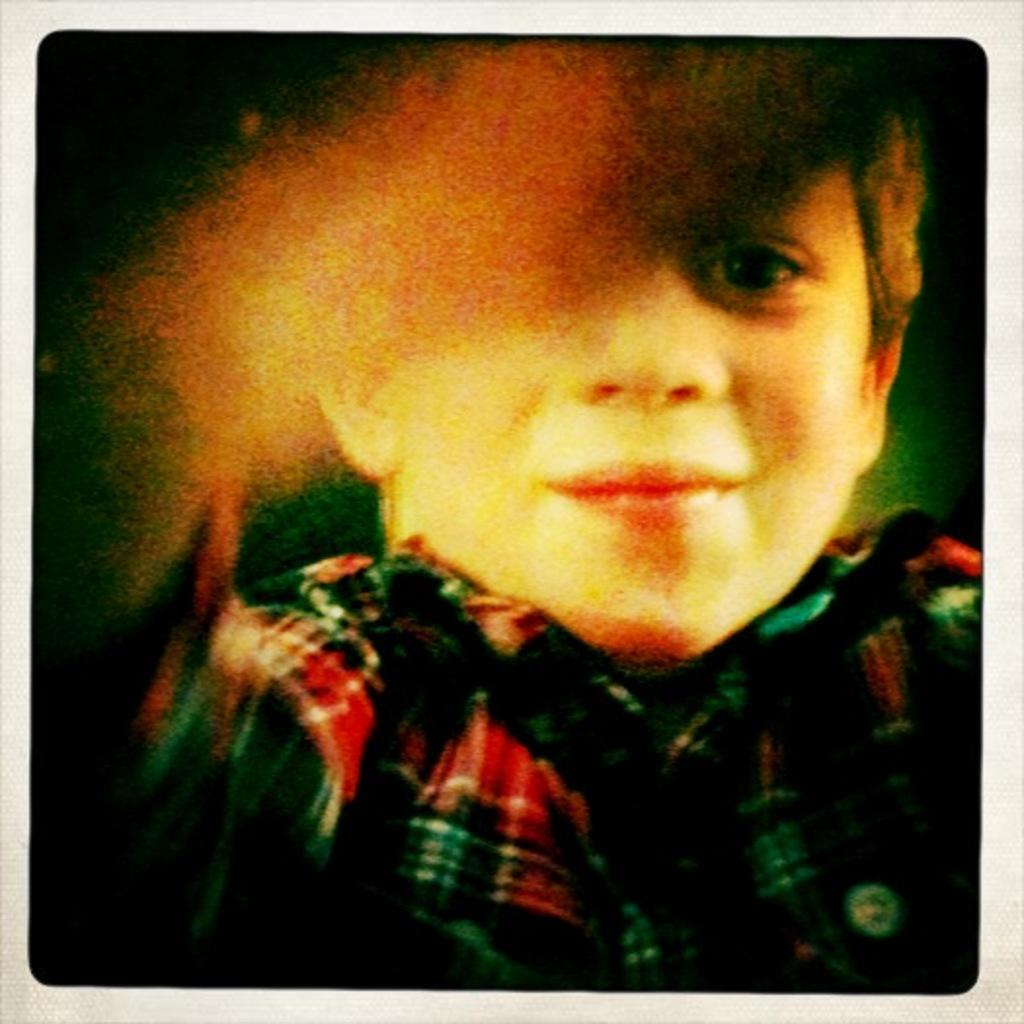What is the main subject of the image? There is a boy in the image. Can you describe the quality of the image? The image is blurred. What does the caption say about the boy's achievements in the image? There is no caption present in the image, and therefore no information about the boy's achievements can be determined. 